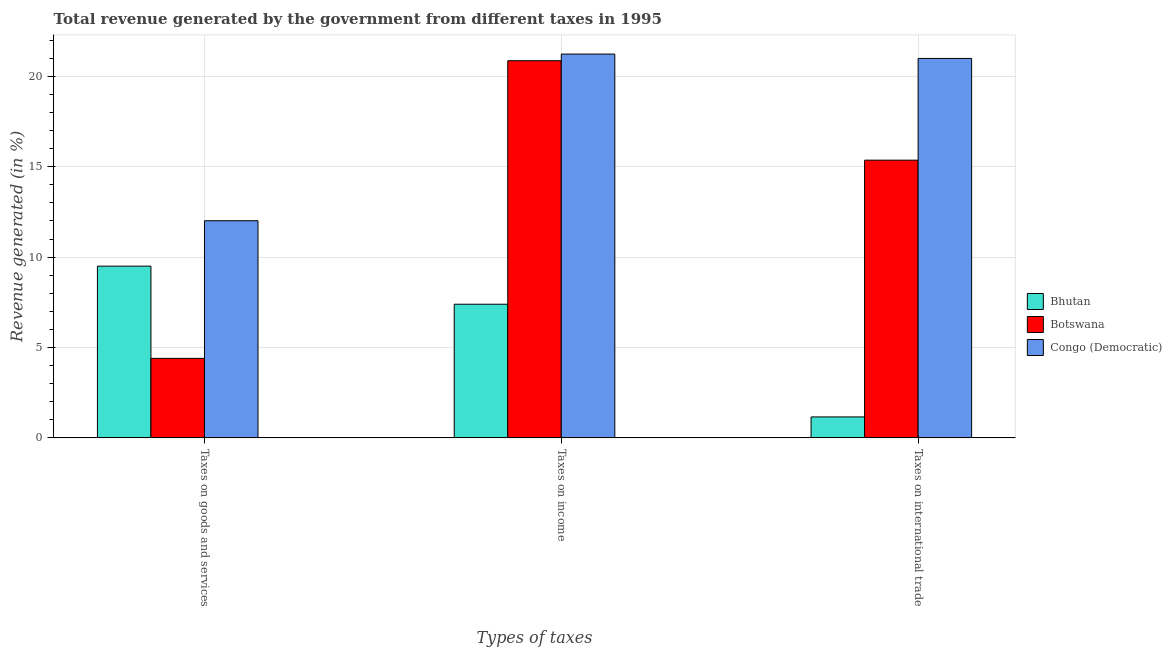How many different coloured bars are there?
Your response must be concise. 3. Are the number of bars on each tick of the X-axis equal?
Keep it short and to the point. Yes. How many bars are there on the 1st tick from the left?
Make the answer very short. 3. What is the label of the 2nd group of bars from the left?
Keep it short and to the point. Taxes on income. What is the percentage of revenue generated by taxes on income in Botswana?
Your answer should be compact. 20.86. Across all countries, what is the maximum percentage of revenue generated by taxes on income?
Your answer should be compact. 21.23. Across all countries, what is the minimum percentage of revenue generated by taxes on goods and services?
Provide a succinct answer. 4.4. In which country was the percentage of revenue generated by taxes on goods and services maximum?
Offer a very short reply. Congo (Democratic). In which country was the percentage of revenue generated by tax on international trade minimum?
Your answer should be compact. Bhutan. What is the total percentage of revenue generated by taxes on goods and services in the graph?
Provide a short and direct response. 25.91. What is the difference between the percentage of revenue generated by taxes on goods and services in Botswana and that in Congo (Democratic)?
Your answer should be compact. -7.61. What is the difference between the percentage of revenue generated by taxes on income in Congo (Democratic) and the percentage of revenue generated by tax on international trade in Botswana?
Provide a succinct answer. 5.87. What is the average percentage of revenue generated by taxes on goods and services per country?
Offer a very short reply. 8.64. What is the difference between the percentage of revenue generated by taxes on income and percentage of revenue generated by taxes on goods and services in Botswana?
Ensure brevity in your answer.  16.47. In how many countries, is the percentage of revenue generated by tax on international trade greater than 1 %?
Keep it short and to the point. 3. What is the ratio of the percentage of revenue generated by taxes on income in Congo (Democratic) to that in Botswana?
Ensure brevity in your answer.  1.02. Is the percentage of revenue generated by taxes on income in Congo (Democratic) less than that in Botswana?
Offer a very short reply. No. Is the difference between the percentage of revenue generated by tax on international trade in Bhutan and Congo (Democratic) greater than the difference between the percentage of revenue generated by taxes on income in Bhutan and Congo (Democratic)?
Your answer should be very brief. No. What is the difference between the highest and the second highest percentage of revenue generated by taxes on goods and services?
Provide a succinct answer. 2.51. What is the difference between the highest and the lowest percentage of revenue generated by tax on international trade?
Keep it short and to the point. 19.83. What does the 3rd bar from the left in Taxes on income represents?
Your answer should be compact. Congo (Democratic). What does the 3rd bar from the right in Taxes on income represents?
Offer a terse response. Bhutan. Is it the case that in every country, the sum of the percentage of revenue generated by taxes on goods and services and percentage of revenue generated by taxes on income is greater than the percentage of revenue generated by tax on international trade?
Keep it short and to the point. Yes. Are all the bars in the graph horizontal?
Your response must be concise. No. How many legend labels are there?
Provide a succinct answer. 3. How are the legend labels stacked?
Keep it short and to the point. Vertical. What is the title of the graph?
Make the answer very short. Total revenue generated by the government from different taxes in 1995. What is the label or title of the X-axis?
Your response must be concise. Types of taxes. What is the label or title of the Y-axis?
Ensure brevity in your answer.  Revenue generated (in %). What is the Revenue generated (in %) in Bhutan in Taxes on goods and services?
Provide a succinct answer. 9.5. What is the Revenue generated (in %) of Botswana in Taxes on goods and services?
Keep it short and to the point. 4.4. What is the Revenue generated (in %) of Congo (Democratic) in Taxes on goods and services?
Provide a succinct answer. 12.01. What is the Revenue generated (in %) of Bhutan in Taxes on income?
Your answer should be very brief. 7.39. What is the Revenue generated (in %) in Botswana in Taxes on income?
Your response must be concise. 20.86. What is the Revenue generated (in %) of Congo (Democratic) in Taxes on income?
Make the answer very short. 21.23. What is the Revenue generated (in %) of Bhutan in Taxes on international trade?
Offer a very short reply. 1.16. What is the Revenue generated (in %) in Botswana in Taxes on international trade?
Make the answer very short. 15.36. What is the Revenue generated (in %) in Congo (Democratic) in Taxes on international trade?
Ensure brevity in your answer.  20.99. Across all Types of taxes, what is the maximum Revenue generated (in %) in Bhutan?
Offer a very short reply. 9.5. Across all Types of taxes, what is the maximum Revenue generated (in %) of Botswana?
Provide a short and direct response. 20.86. Across all Types of taxes, what is the maximum Revenue generated (in %) in Congo (Democratic)?
Keep it short and to the point. 21.23. Across all Types of taxes, what is the minimum Revenue generated (in %) of Bhutan?
Make the answer very short. 1.16. Across all Types of taxes, what is the minimum Revenue generated (in %) in Botswana?
Keep it short and to the point. 4.4. Across all Types of taxes, what is the minimum Revenue generated (in %) of Congo (Democratic)?
Offer a terse response. 12.01. What is the total Revenue generated (in %) in Bhutan in the graph?
Offer a very short reply. 18.05. What is the total Revenue generated (in %) in Botswana in the graph?
Ensure brevity in your answer.  40.62. What is the total Revenue generated (in %) in Congo (Democratic) in the graph?
Ensure brevity in your answer.  54.23. What is the difference between the Revenue generated (in %) in Bhutan in Taxes on goods and services and that in Taxes on income?
Offer a very short reply. 2.11. What is the difference between the Revenue generated (in %) of Botswana in Taxes on goods and services and that in Taxes on income?
Your answer should be very brief. -16.47. What is the difference between the Revenue generated (in %) of Congo (Democratic) in Taxes on goods and services and that in Taxes on income?
Your response must be concise. -9.22. What is the difference between the Revenue generated (in %) of Bhutan in Taxes on goods and services and that in Taxes on international trade?
Your response must be concise. 8.34. What is the difference between the Revenue generated (in %) of Botswana in Taxes on goods and services and that in Taxes on international trade?
Provide a succinct answer. -10.96. What is the difference between the Revenue generated (in %) in Congo (Democratic) in Taxes on goods and services and that in Taxes on international trade?
Give a very brief answer. -8.98. What is the difference between the Revenue generated (in %) of Bhutan in Taxes on income and that in Taxes on international trade?
Your response must be concise. 6.23. What is the difference between the Revenue generated (in %) of Botswana in Taxes on income and that in Taxes on international trade?
Offer a very short reply. 5.5. What is the difference between the Revenue generated (in %) of Congo (Democratic) in Taxes on income and that in Taxes on international trade?
Provide a succinct answer. 0.24. What is the difference between the Revenue generated (in %) of Bhutan in Taxes on goods and services and the Revenue generated (in %) of Botswana in Taxes on income?
Ensure brevity in your answer.  -11.36. What is the difference between the Revenue generated (in %) of Bhutan in Taxes on goods and services and the Revenue generated (in %) of Congo (Democratic) in Taxes on income?
Keep it short and to the point. -11.73. What is the difference between the Revenue generated (in %) of Botswana in Taxes on goods and services and the Revenue generated (in %) of Congo (Democratic) in Taxes on income?
Provide a succinct answer. -16.83. What is the difference between the Revenue generated (in %) of Bhutan in Taxes on goods and services and the Revenue generated (in %) of Botswana in Taxes on international trade?
Your answer should be very brief. -5.86. What is the difference between the Revenue generated (in %) of Bhutan in Taxes on goods and services and the Revenue generated (in %) of Congo (Democratic) in Taxes on international trade?
Keep it short and to the point. -11.49. What is the difference between the Revenue generated (in %) of Botswana in Taxes on goods and services and the Revenue generated (in %) of Congo (Democratic) in Taxes on international trade?
Your response must be concise. -16.59. What is the difference between the Revenue generated (in %) in Bhutan in Taxes on income and the Revenue generated (in %) in Botswana in Taxes on international trade?
Offer a terse response. -7.97. What is the difference between the Revenue generated (in %) in Bhutan in Taxes on income and the Revenue generated (in %) in Congo (Democratic) in Taxes on international trade?
Your answer should be compact. -13.6. What is the difference between the Revenue generated (in %) of Botswana in Taxes on income and the Revenue generated (in %) of Congo (Democratic) in Taxes on international trade?
Give a very brief answer. -0.13. What is the average Revenue generated (in %) of Bhutan per Types of taxes?
Your answer should be very brief. 6.02. What is the average Revenue generated (in %) of Botswana per Types of taxes?
Keep it short and to the point. 13.54. What is the average Revenue generated (in %) of Congo (Democratic) per Types of taxes?
Your response must be concise. 18.08. What is the difference between the Revenue generated (in %) of Bhutan and Revenue generated (in %) of Botswana in Taxes on goods and services?
Your answer should be very brief. 5.1. What is the difference between the Revenue generated (in %) in Bhutan and Revenue generated (in %) in Congo (Democratic) in Taxes on goods and services?
Provide a short and direct response. -2.51. What is the difference between the Revenue generated (in %) of Botswana and Revenue generated (in %) of Congo (Democratic) in Taxes on goods and services?
Provide a short and direct response. -7.61. What is the difference between the Revenue generated (in %) of Bhutan and Revenue generated (in %) of Botswana in Taxes on income?
Keep it short and to the point. -13.47. What is the difference between the Revenue generated (in %) of Bhutan and Revenue generated (in %) of Congo (Democratic) in Taxes on income?
Give a very brief answer. -13.84. What is the difference between the Revenue generated (in %) of Botswana and Revenue generated (in %) of Congo (Democratic) in Taxes on income?
Provide a succinct answer. -0.37. What is the difference between the Revenue generated (in %) of Bhutan and Revenue generated (in %) of Botswana in Taxes on international trade?
Offer a very short reply. -14.2. What is the difference between the Revenue generated (in %) in Bhutan and Revenue generated (in %) in Congo (Democratic) in Taxes on international trade?
Give a very brief answer. -19.83. What is the difference between the Revenue generated (in %) in Botswana and Revenue generated (in %) in Congo (Democratic) in Taxes on international trade?
Ensure brevity in your answer.  -5.63. What is the ratio of the Revenue generated (in %) of Bhutan in Taxes on goods and services to that in Taxes on income?
Keep it short and to the point. 1.28. What is the ratio of the Revenue generated (in %) of Botswana in Taxes on goods and services to that in Taxes on income?
Offer a terse response. 0.21. What is the ratio of the Revenue generated (in %) in Congo (Democratic) in Taxes on goods and services to that in Taxes on income?
Ensure brevity in your answer.  0.57. What is the ratio of the Revenue generated (in %) in Bhutan in Taxes on goods and services to that in Taxes on international trade?
Offer a terse response. 8.2. What is the ratio of the Revenue generated (in %) in Botswana in Taxes on goods and services to that in Taxes on international trade?
Offer a terse response. 0.29. What is the ratio of the Revenue generated (in %) in Congo (Democratic) in Taxes on goods and services to that in Taxes on international trade?
Offer a terse response. 0.57. What is the ratio of the Revenue generated (in %) of Bhutan in Taxes on income to that in Taxes on international trade?
Offer a very short reply. 6.38. What is the ratio of the Revenue generated (in %) in Botswana in Taxes on income to that in Taxes on international trade?
Provide a succinct answer. 1.36. What is the ratio of the Revenue generated (in %) in Congo (Democratic) in Taxes on income to that in Taxes on international trade?
Make the answer very short. 1.01. What is the difference between the highest and the second highest Revenue generated (in %) of Bhutan?
Give a very brief answer. 2.11. What is the difference between the highest and the second highest Revenue generated (in %) of Botswana?
Keep it short and to the point. 5.5. What is the difference between the highest and the second highest Revenue generated (in %) in Congo (Democratic)?
Offer a very short reply. 0.24. What is the difference between the highest and the lowest Revenue generated (in %) of Bhutan?
Give a very brief answer. 8.34. What is the difference between the highest and the lowest Revenue generated (in %) of Botswana?
Your answer should be very brief. 16.47. What is the difference between the highest and the lowest Revenue generated (in %) in Congo (Democratic)?
Keep it short and to the point. 9.22. 